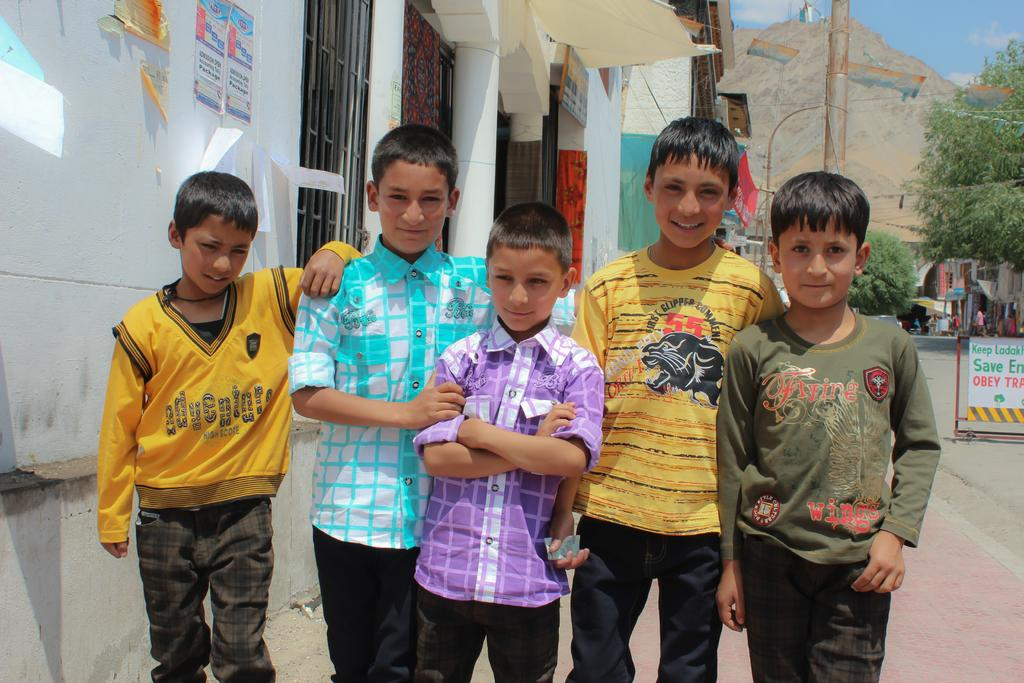What is the main subject of the image? The main subject of the image is a group of boys. What are the boys doing in the image? The boys are standing and smiling in the image. What can be seen on the left side of the image? There is a building on the left side of the image. What type of vegetation is on the right side of the image? There are trees on the right side of the image. What is visible at the top of the image? The sky is visible at the top of the image. What type of quilt is being used to cover the boys in the image? There is no quilt present in the image; the boys are standing and not covered by any fabric. How many squares can be seen on the building in the image? The image does not provide enough detail to determine the number of squares on the building. 